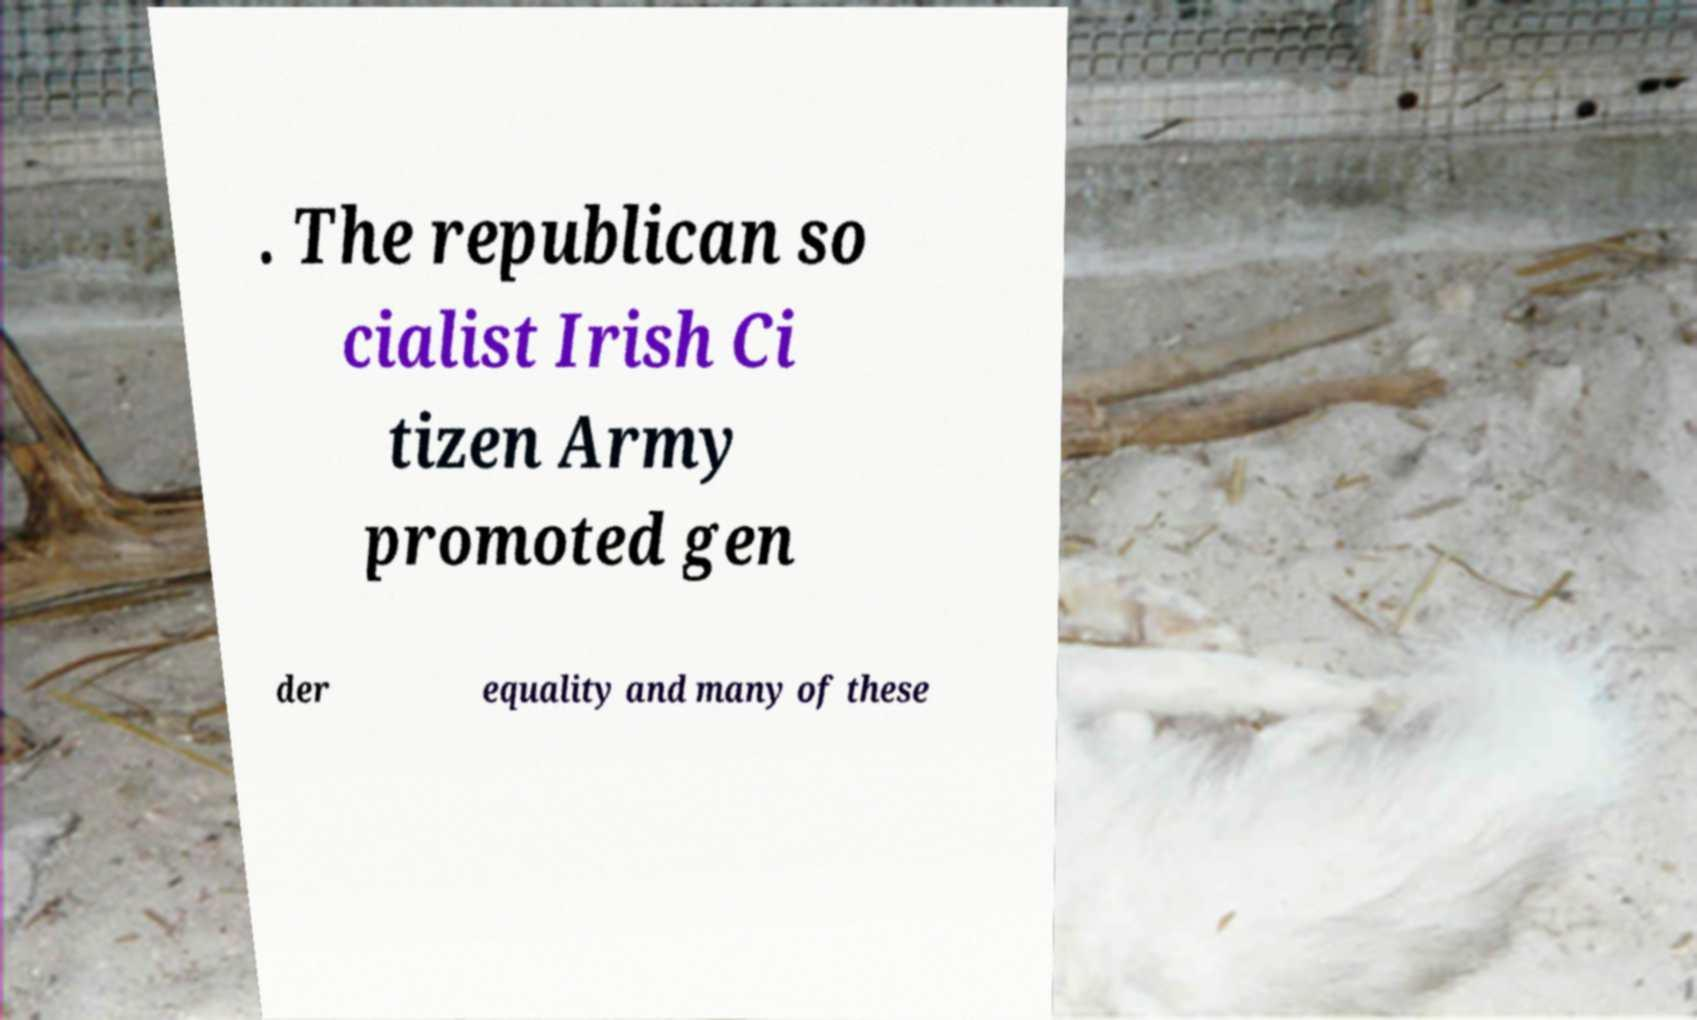For documentation purposes, I need the text within this image transcribed. Could you provide that? . The republican so cialist Irish Ci tizen Army promoted gen der equality and many of these 